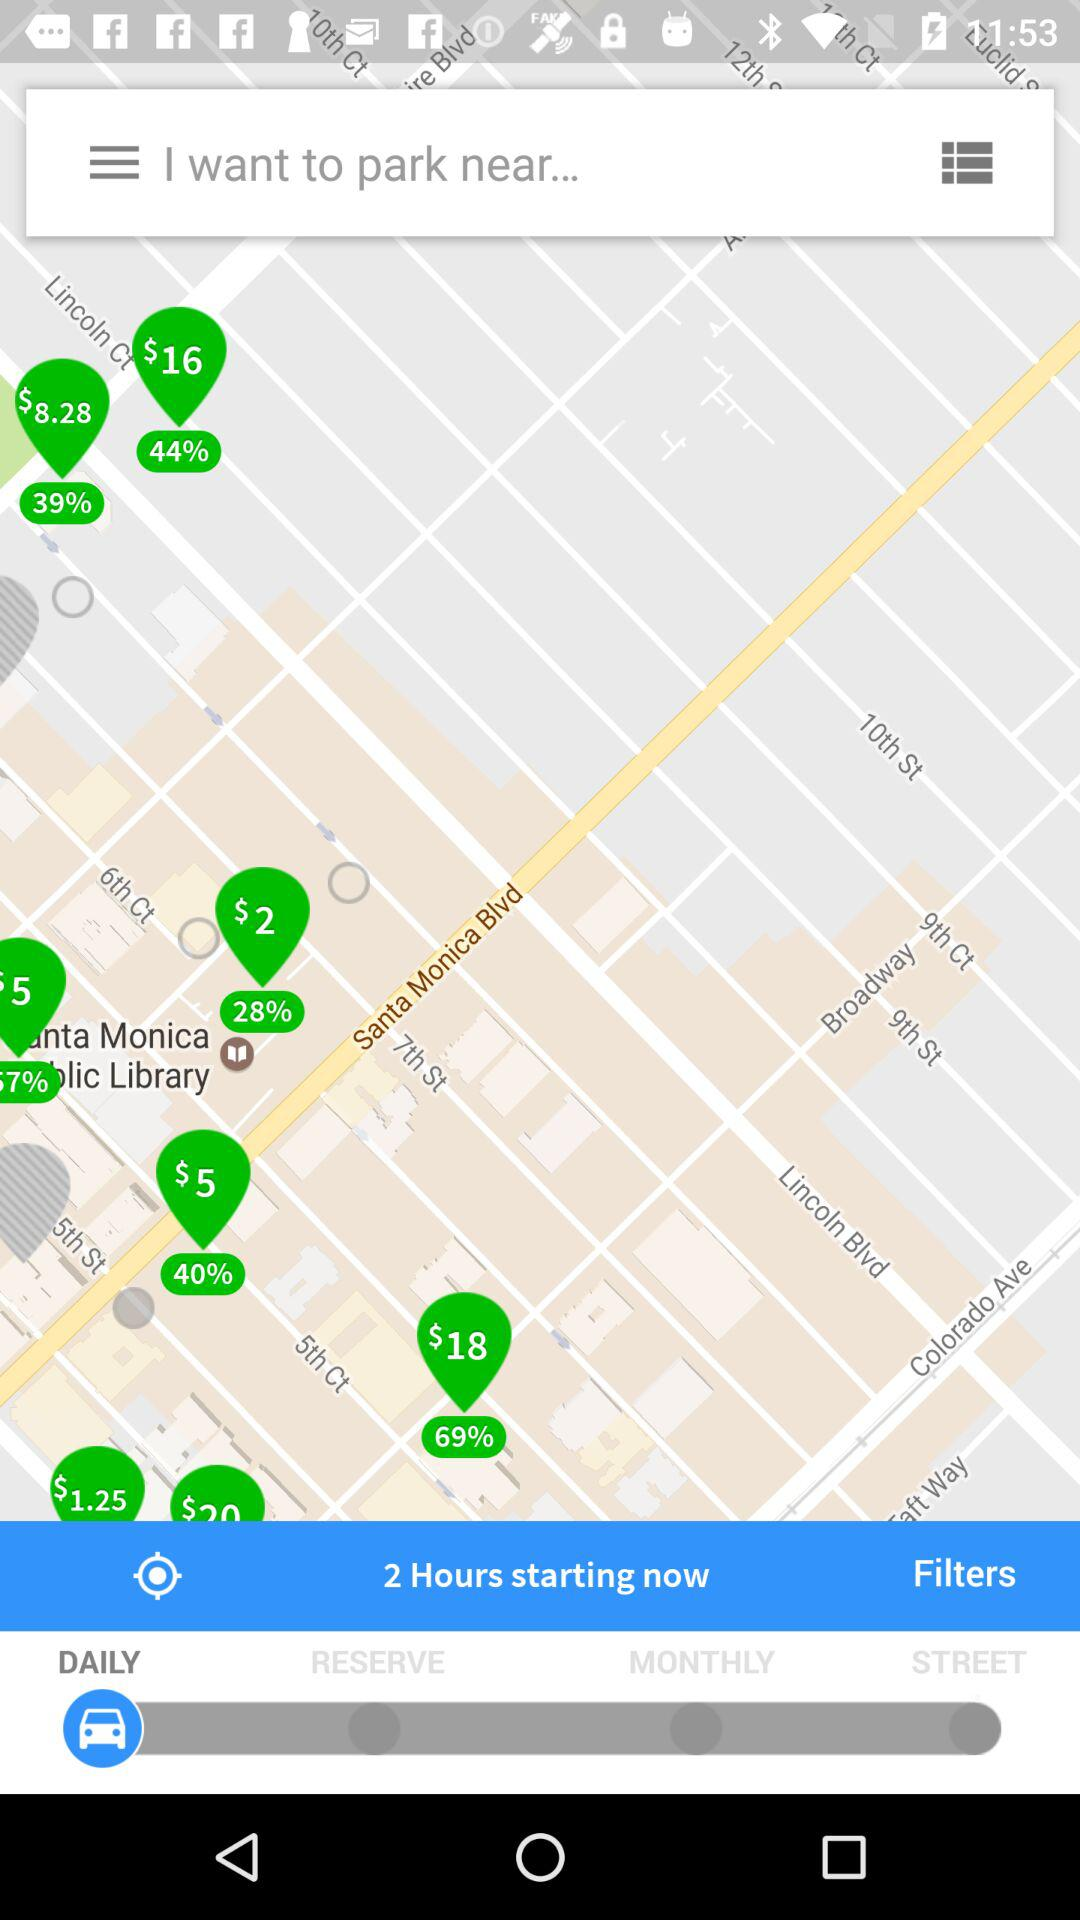Which tab is selected? The selected tab is "DAILY". 